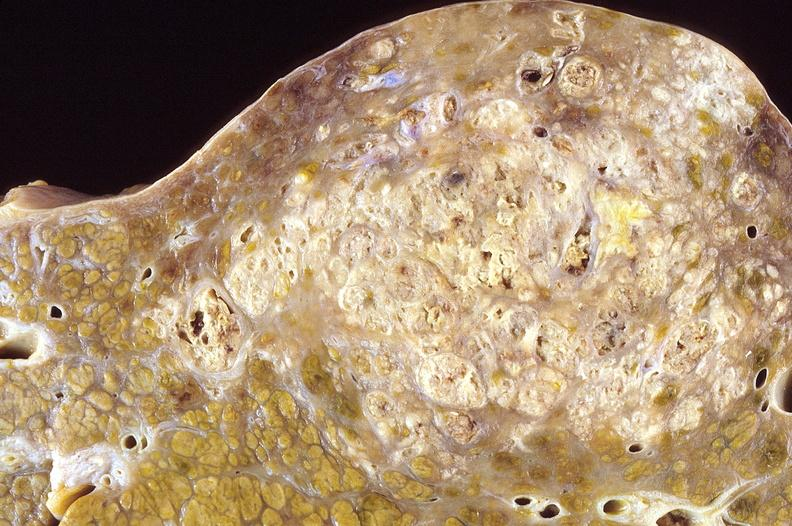s female reproductive present?
Answer the question using a single word or phrase. No 